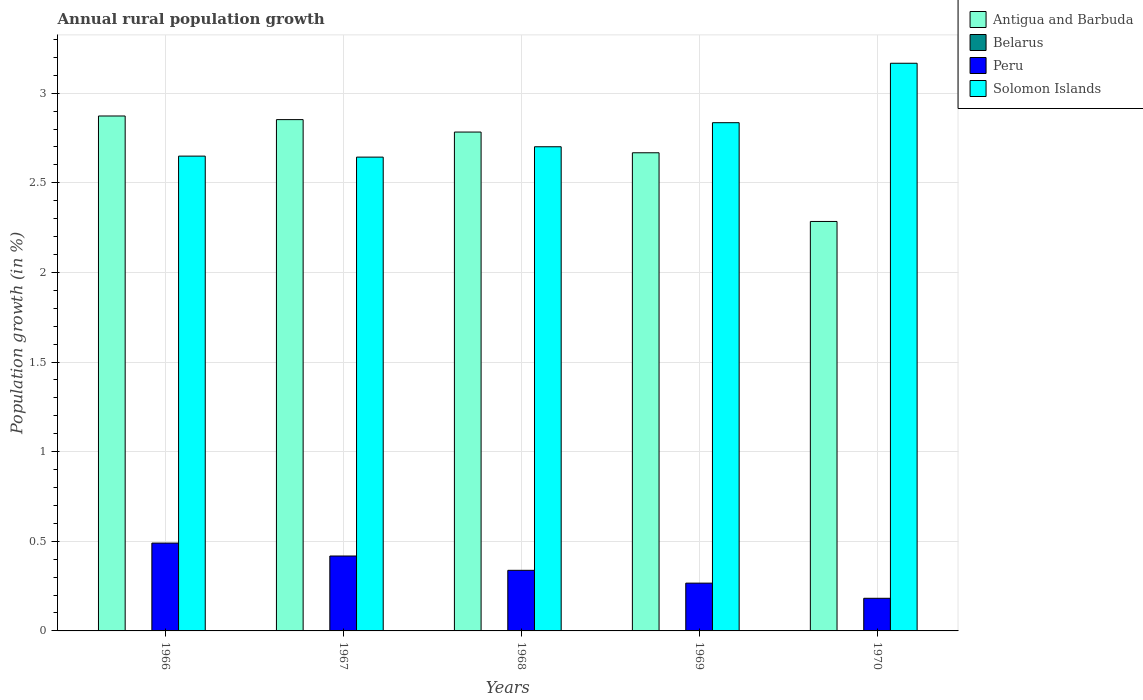How many groups of bars are there?
Keep it short and to the point. 5. Are the number of bars per tick equal to the number of legend labels?
Provide a short and direct response. No. What is the label of the 3rd group of bars from the left?
Your response must be concise. 1968. Across all years, what is the maximum percentage of rural population growth in Solomon Islands?
Provide a short and direct response. 3.17. Across all years, what is the minimum percentage of rural population growth in Peru?
Offer a very short reply. 0.18. In which year was the percentage of rural population growth in Peru maximum?
Provide a short and direct response. 1966. What is the total percentage of rural population growth in Antigua and Barbuda in the graph?
Keep it short and to the point. 13.46. What is the difference between the percentage of rural population growth in Peru in 1967 and that in 1969?
Make the answer very short. 0.15. What is the difference between the percentage of rural population growth in Antigua and Barbuda in 1969 and the percentage of rural population growth in Solomon Islands in 1966?
Keep it short and to the point. 0.02. In the year 1968, what is the difference between the percentage of rural population growth in Solomon Islands and percentage of rural population growth in Peru?
Provide a succinct answer. 2.36. In how many years, is the percentage of rural population growth in Peru greater than 0.2 %?
Ensure brevity in your answer.  4. What is the ratio of the percentage of rural population growth in Solomon Islands in 1967 to that in 1969?
Give a very brief answer. 0.93. Is the percentage of rural population growth in Peru in 1967 less than that in 1969?
Keep it short and to the point. No. What is the difference between the highest and the second highest percentage of rural population growth in Antigua and Barbuda?
Give a very brief answer. 0.02. What is the difference between the highest and the lowest percentage of rural population growth in Peru?
Ensure brevity in your answer.  0.31. Is the sum of the percentage of rural population growth in Antigua and Barbuda in 1969 and 1970 greater than the maximum percentage of rural population growth in Peru across all years?
Your answer should be compact. Yes. Is it the case that in every year, the sum of the percentage of rural population growth in Antigua and Barbuda and percentage of rural population growth in Peru is greater than the sum of percentage of rural population growth in Belarus and percentage of rural population growth in Solomon Islands?
Your answer should be compact. Yes. Is it the case that in every year, the sum of the percentage of rural population growth in Solomon Islands and percentage of rural population growth in Peru is greater than the percentage of rural population growth in Belarus?
Keep it short and to the point. Yes. How many years are there in the graph?
Provide a succinct answer. 5. Does the graph contain any zero values?
Provide a short and direct response. Yes. Where does the legend appear in the graph?
Give a very brief answer. Top right. How many legend labels are there?
Give a very brief answer. 4. How are the legend labels stacked?
Provide a short and direct response. Vertical. What is the title of the graph?
Make the answer very short. Annual rural population growth. What is the label or title of the Y-axis?
Make the answer very short. Population growth (in %). What is the Population growth (in %) in Antigua and Barbuda in 1966?
Your answer should be very brief. 2.87. What is the Population growth (in %) in Peru in 1966?
Ensure brevity in your answer.  0.49. What is the Population growth (in %) in Solomon Islands in 1966?
Keep it short and to the point. 2.65. What is the Population growth (in %) in Antigua and Barbuda in 1967?
Keep it short and to the point. 2.85. What is the Population growth (in %) of Peru in 1967?
Your answer should be very brief. 0.42. What is the Population growth (in %) of Solomon Islands in 1967?
Your answer should be very brief. 2.64. What is the Population growth (in %) in Antigua and Barbuda in 1968?
Your answer should be very brief. 2.78. What is the Population growth (in %) in Peru in 1968?
Provide a short and direct response. 0.34. What is the Population growth (in %) of Solomon Islands in 1968?
Give a very brief answer. 2.7. What is the Population growth (in %) of Antigua and Barbuda in 1969?
Your response must be concise. 2.67. What is the Population growth (in %) in Belarus in 1969?
Your response must be concise. 0. What is the Population growth (in %) of Peru in 1969?
Provide a short and direct response. 0.27. What is the Population growth (in %) in Solomon Islands in 1969?
Give a very brief answer. 2.84. What is the Population growth (in %) of Antigua and Barbuda in 1970?
Your response must be concise. 2.28. What is the Population growth (in %) of Belarus in 1970?
Ensure brevity in your answer.  0. What is the Population growth (in %) in Peru in 1970?
Keep it short and to the point. 0.18. What is the Population growth (in %) of Solomon Islands in 1970?
Your response must be concise. 3.17. Across all years, what is the maximum Population growth (in %) in Antigua and Barbuda?
Offer a terse response. 2.87. Across all years, what is the maximum Population growth (in %) in Peru?
Provide a short and direct response. 0.49. Across all years, what is the maximum Population growth (in %) in Solomon Islands?
Offer a terse response. 3.17. Across all years, what is the minimum Population growth (in %) in Antigua and Barbuda?
Ensure brevity in your answer.  2.28. Across all years, what is the minimum Population growth (in %) of Peru?
Your answer should be very brief. 0.18. Across all years, what is the minimum Population growth (in %) of Solomon Islands?
Your response must be concise. 2.64. What is the total Population growth (in %) in Antigua and Barbuda in the graph?
Make the answer very short. 13.46. What is the total Population growth (in %) in Peru in the graph?
Your answer should be compact. 1.69. What is the total Population growth (in %) of Solomon Islands in the graph?
Offer a very short reply. 13.99. What is the difference between the Population growth (in %) of Antigua and Barbuda in 1966 and that in 1967?
Offer a terse response. 0.02. What is the difference between the Population growth (in %) in Peru in 1966 and that in 1967?
Provide a short and direct response. 0.07. What is the difference between the Population growth (in %) of Solomon Islands in 1966 and that in 1967?
Ensure brevity in your answer.  0.01. What is the difference between the Population growth (in %) in Antigua and Barbuda in 1966 and that in 1968?
Give a very brief answer. 0.09. What is the difference between the Population growth (in %) of Peru in 1966 and that in 1968?
Offer a very short reply. 0.15. What is the difference between the Population growth (in %) in Solomon Islands in 1966 and that in 1968?
Keep it short and to the point. -0.05. What is the difference between the Population growth (in %) in Antigua and Barbuda in 1966 and that in 1969?
Your answer should be compact. 0.21. What is the difference between the Population growth (in %) in Peru in 1966 and that in 1969?
Provide a succinct answer. 0.22. What is the difference between the Population growth (in %) of Solomon Islands in 1966 and that in 1969?
Offer a terse response. -0.19. What is the difference between the Population growth (in %) in Antigua and Barbuda in 1966 and that in 1970?
Your answer should be very brief. 0.59. What is the difference between the Population growth (in %) in Peru in 1966 and that in 1970?
Your answer should be very brief. 0.31. What is the difference between the Population growth (in %) of Solomon Islands in 1966 and that in 1970?
Provide a succinct answer. -0.52. What is the difference between the Population growth (in %) in Antigua and Barbuda in 1967 and that in 1968?
Provide a succinct answer. 0.07. What is the difference between the Population growth (in %) of Peru in 1967 and that in 1968?
Keep it short and to the point. 0.08. What is the difference between the Population growth (in %) in Solomon Islands in 1967 and that in 1968?
Keep it short and to the point. -0.06. What is the difference between the Population growth (in %) of Antigua and Barbuda in 1967 and that in 1969?
Offer a terse response. 0.18. What is the difference between the Population growth (in %) in Peru in 1967 and that in 1969?
Offer a terse response. 0.15. What is the difference between the Population growth (in %) in Solomon Islands in 1967 and that in 1969?
Keep it short and to the point. -0.19. What is the difference between the Population growth (in %) of Antigua and Barbuda in 1967 and that in 1970?
Your answer should be very brief. 0.57. What is the difference between the Population growth (in %) of Peru in 1967 and that in 1970?
Provide a short and direct response. 0.24. What is the difference between the Population growth (in %) in Solomon Islands in 1967 and that in 1970?
Give a very brief answer. -0.52. What is the difference between the Population growth (in %) of Antigua and Barbuda in 1968 and that in 1969?
Your answer should be very brief. 0.12. What is the difference between the Population growth (in %) in Peru in 1968 and that in 1969?
Ensure brevity in your answer.  0.07. What is the difference between the Population growth (in %) of Solomon Islands in 1968 and that in 1969?
Provide a short and direct response. -0.13. What is the difference between the Population growth (in %) of Antigua and Barbuda in 1968 and that in 1970?
Ensure brevity in your answer.  0.5. What is the difference between the Population growth (in %) in Peru in 1968 and that in 1970?
Your answer should be very brief. 0.16. What is the difference between the Population growth (in %) in Solomon Islands in 1968 and that in 1970?
Offer a terse response. -0.47. What is the difference between the Population growth (in %) in Antigua and Barbuda in 1969 and that in 1970?
Your answer should be compact. 0.38. What is the difference between the Population growth (in %) in Peru in 1969 and that in 1970?
Offer a very short reply. 0.08. What is the difference between the Population growth (in %) of Solomon Islands in 1969 and that in 1970?
Provide a short and direct response. -0.33. What is the difference between the Population growth (in %) of Antigua and Barbuda in 1966 and the Population growth (in %) of Peru in 1967?
Ensure brevity in your answer.  2.45. What is the difference between the Population growth (in %) of Antigua and Barbuda in 1966 and the Population growth (in %) of Solomon Islands in 1967?
Offer a terse response. 0.23. What is the difference between the Population growth (in %) in Peru in 1966 and the Population growth (in %) in Solomon Islands in 1967?
Offer a terse response. -2.15. What is the difference between the Population growth (in %) in Antigua and Barbuda in 1966 and the Population growth (in %) in Peru in 1968?
Provide a succinct answer. 2.53. What is the difference between the Population growth (in %) of Antigua and Barbuda in 1966 and the Population growth (in %) of Solomon Islands in 1968?
Keep it short and to the point. 0.17. What is the difference between the Population growth (in %) of Peru in 1966 and the Population growth (in %) of Solomon Islands in 1968?
Ensure brevity in your answer.  -2.21. What is the difference between the Population growth (in %) in Antigua and Barbuda in 1966 and the Population growth (in %) in Peru in 1969?
Give a very brief answer. 2.61. What is the difference between the Population growth (in %) in Antigua and Barbuda in 1966 and the Population growth (in %) in Solomon Islands in 1969?
Provide a short and direct response. 0.04. What is the difference between the Population growth (in %) of Peru in 1966 and the Population growth (in %) of Solomon Islands in 1969?
Offer a very short reply. -2.35. What is the difference between the Population growth (in %) of Antigua and Barbuda in 1966 and the Population growth (in %) of Peru in 1970?
Keep it short and to the point. 2.69. What is the difference between the Population growth (in %) in Antigua and Barbuda in 1966 and the Population growth (in %) in Solomon Islands in 1970?
Give a very brief answer. -0.29. What is the difference between the Population growth (in %) of Peru in 1966 and the Population growth (in %) of Solomon Islands in 1970?
Provide a succinct answer. -2.68. What is the difference between the Population growth (in %) of Antigua and Barbuda in 1967 and the Population growth (in %) of Peru in 1968?
Offer a very short reply. 2.51. What is the difference between the Population growth (in %) in Antigua and Barbuda in 1967 and the Population growth (in %) in Solomon Islands in 1968?
Your answer should be very brief. 0.15. What is the difference between the Population growth (in %) in Peru in 1967 and the Population growth (in %) in Solomon Islands in 1968?
Your response must be concise. -2.28. What is the difference between the Population growth (in %) in Antigua and Barbuda in 1967 and the Population growth (in %) in Peru in 1969?
Provide a short and direct response. 2.59. What is the difference between the Population growth (in %) of Antigua and Barbuda in 1967 and the Population growth (in %) of Solomon Islands in 1969?
Your response must be concise. 0.02. What is the difference between the Population growth (in %) in Peru in 1967 and the Population growth (in %) in Solomon Islands in 1969?
Offer a terse response. -2.42. What is the difference between the Population growth (in %) of Antigua and Barbuda in 1967 and the Population growth (in %) of Peru in 1970?
Provide a short and direct response. 2.67. What is the difference between the Population growth (in %) in Antigua and Barbuda in 1967 and the Population growth (in %) in Solomon Islands in 1970?
Give a very brief answer. -0.31. What is the difference between the Population growth (in %) of Peru in 1967 and the Population growth (in %) of Solomon Islands in 1970?
Your answer should be compact. -2.75. What is the difference between the Population growth (in %) in Antigua and Barbuda in 1968 and the Population growth (in %) in Peru in 1969?
Offer a very short reply. 2.52. What is the difference between the Population growth (in %) in Antigua and Barbuda in 1968 and the Population growth (in %) in Solomon Islands in 1969?
Provide a short and direct response. -0.05. What is the difference between the Population growth (in %) in Peru in 1968 and the Population growth (in %) in Solomon Islands in 1969?
Your answer should be compact. -2.5. What is the difference between the Population growth (in %) of Antigua and Barbuda in 1968 and the Population growth (in %) of Peru in 1970?
Offer a terse response. 2.6. What is the difference between the Population growth (in %) in Antigua and Barbuda in 1968 and the Population growth (in %) in Solomon Islands in 1970?
Provide a succinct answer. -0.38. What is the difference between the Population growth (in %) of Peru in 1968 and the Population growth (in %) of Solomon Islands in 1970?
Provide a short and direct response. -2.83. What is the difference between the Population growth (in %) in Antigua and Barbuda in 1969 and the Population growth (in %) in Peru in 1970?
Offer a very short reply. 2.49. What is the difference between the Population growth (in %) of Antigua and Barbuda in 1969 and the Population growth (in %) of Solomon Islands in 1970?
Keep it short and to the point. -0.5. What is the difference between the Population growth (in %) in Peru in 1969 and the Population growth (in %) in Solomon Islands in 1970?
Offer a terse response. -2.9. What is the average Population growth (in %) of Antigua and Barbuda per year?
Offer a very short reply. 2.69. What is the average Population growth (in %) in Peru per year?
Make the answer very short. 0.34. What is the average Population growth (in %) of Solomon Islands per year?
Make the answer very short. 2.8. In the year 1966, what is the difference between the Population growth (in %) of Antigua and Barbuda and Population growth (in %) of Peru?
Your answer should be very brief. 2.38. In the year 1966, what is the difference between the Population growth (in %) of Antigua and Barbuda and Population growth (in %) of Solomon Islands?
Keep it short and to the point. 0.22. In the year 1966, what is the difference between the Population growth (in %) in Peru and Population growth (in %) in Solomon Islands?
Provide a short and direct response. -2.16. In the year 1967, what is the difference between the Population growth (in %) in Antigua and Barbuda and Population growth (in %) in Peru?
Make the answer very short. 2.43. In the year 1967, what is the difference between the Population growth (in %) of Antigua and Barbuda and Population growth (in %) of Solomon Islands?
Make the answer very short. 0.21. In the year 1967, what is the difference between the Population growth (in %) of Peru and Population growth (in %) of Solomon Islands?
Your response must be concise. -2.23. In the year 1968, what is the difference between the Population growth (in %) in Antigua and Barbuda and Population growth (in %) in Peru?
Make the answer very short. 2.44. In the year 1968, what is the difference between the Population growth (in %) in Antigua and Barbuda and Population growth (in %) in Solomon Islands?
Ensure brevity in your answer.  0.08. In the year 1968, what is the difference between the Population growth (in %) of Peru and Population growth (in %) of Solomon Islands?
Provide a short and direct response. -2.36. In the year 1969, what is the difference between the Population growth (in %) in Antigua and Barbuda and Population growth (in %) in Peru?
Your answer should be very brief. 2.4. In the year 1969, what is the difference between the Population growth (in %) of Antigua and Barbuda and Population growth (in %) of Solomon Islands?
Your response must be concise. -0.17. In the year 1969, what is the difference between the Population growth (in %) of Peru and Population growth (in %) of Solomon Islands?
Give a very brief answer. -2.57. In the year 1970, what is the difference between the Population growth (in %) in Antigua and Barbuda and Population growth (in %) in Peru?
Keep it short and to the point. 2.1. In the year 1970, what is the difference between the Population growth (in %) of Antigua and Barbuda and Population growth (in %) of Solomon Islands?
Keep it short and to the point. -0.88. In the year 1970, what is the difference between the Population growth (in %) of Peru and Population growth (in %) of Solomon Islands?
Provide a succinct answer. -2.98. What is the ratio of the Population growth (in %) of Antigua and Barbuda in 1966 to that in 1967?
Offer a very short reply. 1.01. What is the ratio of the Population growth (in %) in Peru in 1966 to that in 1967?
Make the answer very short. 1.17. What is the ratio of the Population growth (in %) of Antigua and Barbuda in 1966 to that in 1968?
Ensure brevity in your answer.  1.03. What is the ratio of the Population growth (in %) in Peru in 1966 to that in 1968?
Your answer should be very brief. 1.45. What is the ratio of the Population growth (in %) of Solomon Islands in 1966 to that in 1968?
Give a very brief answer. 0.98. What is the ratio of the Population growth (in %) in Antigua and Barbuda in 1966 to that in 1969?
Provide a succinct answer. 1.08. What is the ratio of the Population growth (in %) of Peru in 1966 to that in 1969?
Your response must be concise. 1.84. What is the ratio of the Population growth (in %) in Solomon Islands in 1966 to that in 1969?
Offer a very short reply. 0.93. What is the ratio of the Population growth (in %) in Antigua and Barbuda in 1966 to that in 1970?
Keep it short and to the point. 1.26. What is the ratio of the Population growth (in %) of Peru in 1966 to that in 1970?
Your answer should be compact. 2.69. What is the ratio of the Population growth (in %) in Solomon Islands in 1966 to that in 1970?
Your response must be concise. 0.84. What is the ratio of the Population growth (in %) of Antigua and Barbuda in 1967 to that in 1968?
Offer a very short reply. 1.02. What is the ratio of the Population growth (in %) of Peru in 1967 to that in 1968?
Your response must be concise. 1.24. What is the ratio of the Population growth (in %) of Solomon Islands in 1967 to that in 1968?
Offer a very short reply. 0.98. What is the ratio of the Population growth (in %) in Antigua and Barbuda in 1967 to that in 1969?
Give a very brief answer. 1.07. What is the ratio of the Population growth (in %) in Peru in 1967 to that in 1969?
Provide a succinct answer. 1.57. What is the ratio of the Population growth (in %) of Solomon Islands in 1967 to that in 1969?
Offer a very short reply. 0.93. What is the ratio of the Population growth (in %) of Antigua and Barbuda in 1967 to that in 1970?
Your response must be concise. 1.25. What is the ratio of the Population growth (in %) of Peru in 1967 to that in 1970?
Give a very brief answer. 2.3. What is the ratio of the Population growth (in %) in Solomon Islands in 1967 to that in 1970?
Keep it short and to the point. 0.83. What is the ratio of the Population growth (in %) of Antigua and Barbuda in 1968 to that in 1969?
Provide a short and direct response. 1.04. What is the ratio of the Population growth (in %) of Peru in 1968 to that in 1969?
Give a very brief answer. 1.27. What is the ratio of the Population growth (in %) in Solomon Islands in 1968 to that in 1969?
Offer a terse response. 0.95. What is the ratio of the Population growth (in %) in Antigua and Barbuda in 1968 to that in 1970?
Your answer should be very brief. 1.22. What is the ratio of the Population growth (in %) in Peru in 1968 to that in 1970?
Your answer should be compact. 1.86. What is the ratio of the Population growth (in %) of Solomon Islands in 1968 to that in 1970?
Your answer should be very brief. 0.85. What is the ratio of the Population growth (in %) in Antigua and Barbuda in 1969 to that in 1970?
Your answer should be compact. 1.17. What is the ratio of the Population growth (in %) of Peru in 1969 to that in 1970?
Provide a succinct answer. 1.46. What is the ratio of the Population growth (in %) in Solomon Islands in 1969 to that in 1970?
Provide a succinct answer. 0.9. What is the difference between the highest and the second highest Population growth (in %) of Antigua and Barbuda?
Provide a short and direct response. 0.02. What is the difference between the highest and the second highest Population growth (in %) of Peru?
Offer a very short reply. 0.07. What is the difference between the highest and the second highest Population growth (in %) in Solomon Islands?
Your answer should be very brief. 0.33. What is the difference between the highest and the lowest Population growth (in %) of Antigua and Barbuda?
Your answer should be very brief. 0.59. What is the difference between the highest and the lowest Population growth (in %) of Peru?
Give a very brief answer. 0.31. What is the difference between the highest and the lowest Population growth (in %) of Solomon Islands?
Make the answer very short. 0.52. 